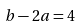<formula> <loc_0><loc_0><loc_500><loc_500>b - 2 a = 4</formula> 